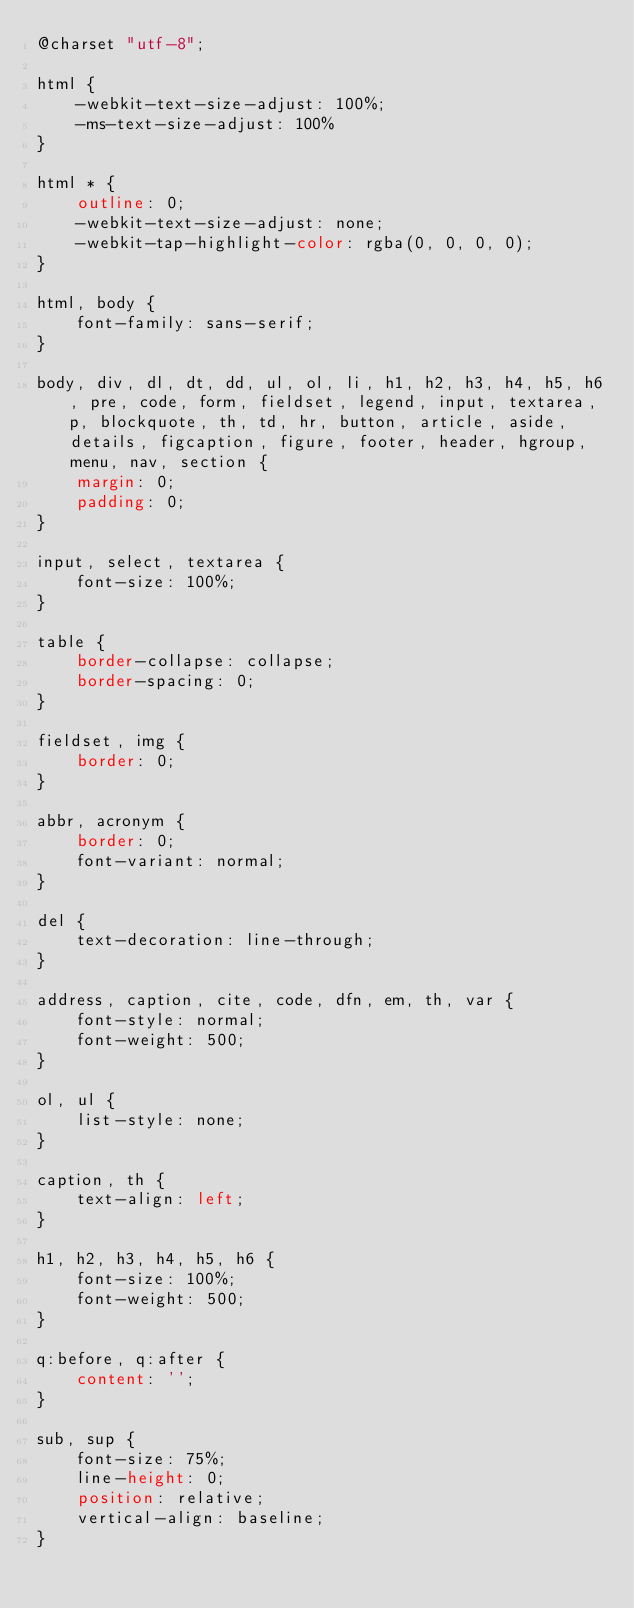Convert code to text. <code><loc_0><loc_0><loc_500><loc_500><_CSS_>@charset "utf-8";

html {
    -webkit-text-size-adjust: 100%;
    -ms-text-size-adjust: 100%
}

html * {
    outline: 0;
    -webkit-text-size-adjust: none;
    -webkit-tap-highlight-color: rgba(0, 0, 0, 0);
}

html, body {
    font-family: sans-serif;
}

body, div, dl, dt, dd, ul, ol, li, h1, h2, h3, h4, h5, h6, pre, code, form, fieldset, legend, input, textarea, p, blockquote, th, td, hr, button, article, aside, details, figcaption, figure, footer, header, hgroup, menu, nav, section {
    margin: 0;
    padding: 0;
}

input, select, textarea {
    font-size: 100%;
}

table {
    border-collapse: collapse;
    border-spacing: 0;
}

fieldset, img {
    border: 0;
}

abbr, acronym {
    border: 0;
    font-variant: normal;
}

del {
    text-decoration: line-through;
}

address, caption, cite, code, dfn, em, th, var {
    font-style: normal;
    font-weight: 500;
}

ol, ul {
    list-style: none;
}

caption, th {
    text-align: left;
}

h1, h2, h3, h4, h5, h6 {
    font-size: 100%;
    font-weight: 500;
}

q:before, q:after {
    content: '';
}

sub, sup {
    font-size: 75%;
    line-height: 0;
    position: relative;
    vertical-align: baseline;
}
</code> 